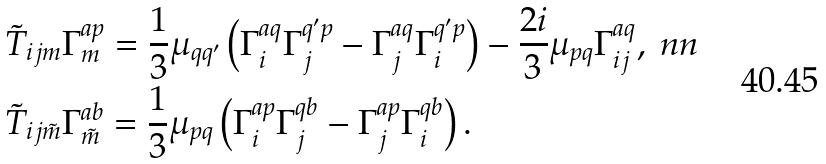<formula> <loc_0><loc_0><loc_500><loc_500>& \tilde { T } _ { i j m } \Gamma _ { m } ^ { a p } = \frac { 1 } 3 \mu _ { q q ^ { \prime } } \left ( \Gamma _ { i } ^ { a q } \Gamma _ { j } ^ { q ^ { \prime } p } - \Gamma _ { j } ^ { a q } \Gamma _ { i } ^ { q ^ { \prime } p } \right ) - \frac { 2 i } 3 \mu _ { p q } \Gamma _ { i j } ^ { a q } , \ n n \\ & \tilde { T } _ { i j \tilde { m } } \Gamma _ { \tilde { m } } ^ { a b } = \frac { 1 } 3 \mu _ { p q } \left ( \Gamma _ { i } ^ { a p } \Gamma _ { j } ^ { q b } - \Gamma _ { j } ^ { a p } \Gamma _ { i } ^ { q b } \right ) .</formula> 